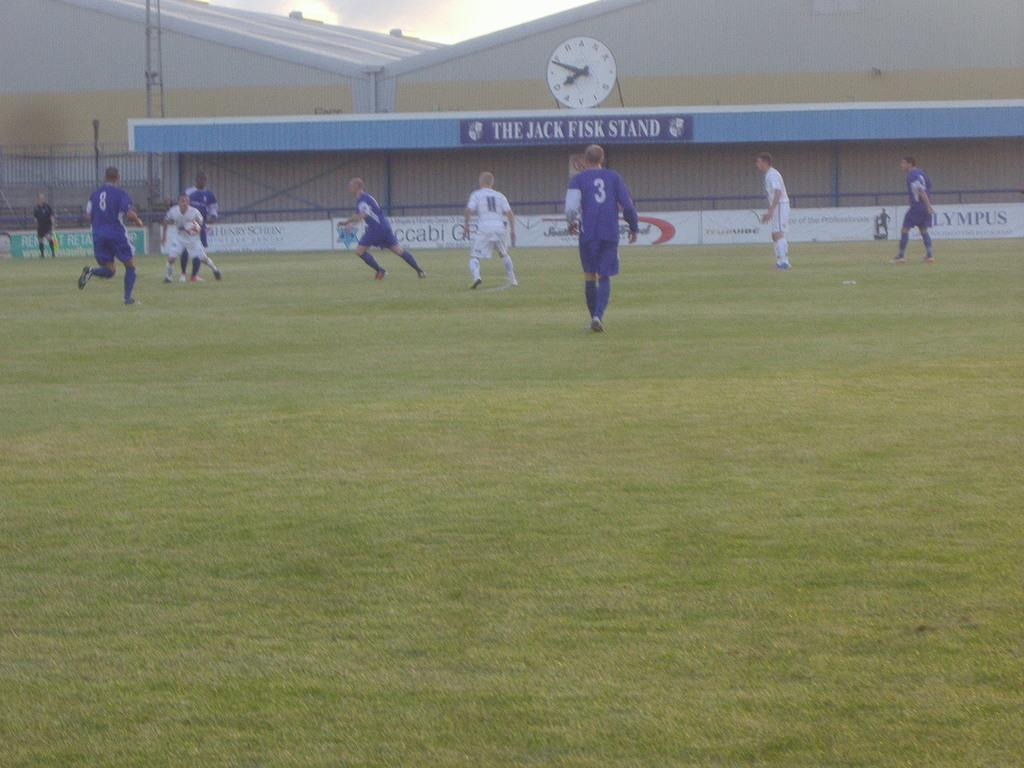<image>
Write a terse but informative summary of the picture. baseball players on the field in front of the jack fisk stand 